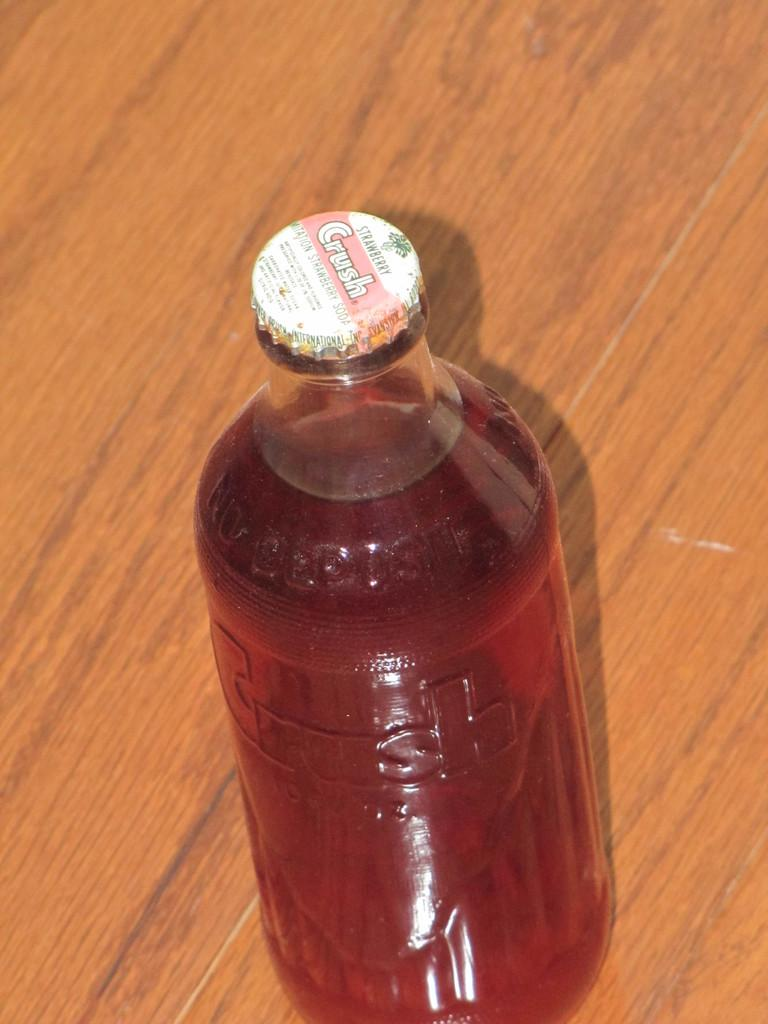What is in the bottle that is visible in the image? The bottle is filled with juice. Where is the bottle located in the image? The bottle is placed on a table. Can you describe the setting of the image? The image appears to be taken inside a room. Can you see the bird taking a bite out of the wing in the image? There is no bird or wing present in the image. 